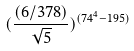<formula> <loc_0><loc_0><loc_500><loc_500>( \frac { ( 6 / 3 7 8 ) } { \sqrt { 5 } } ) ^ { ( 7 4 ^ { 4 } - 1 9 5 ) }</formula> 